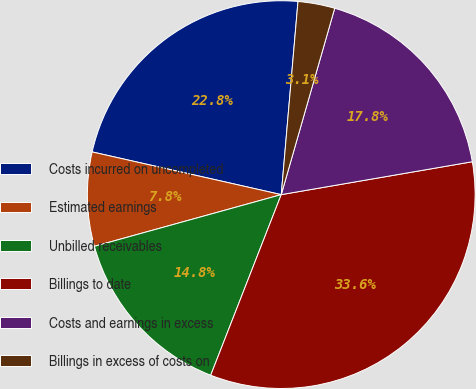Convert chart. <chart><loc_0><loc_0><loc_500><loc_500><pie_chart><fcel>Costs incurred on uncompleted<fcel>Estimated earnings<fcel>Unbilled receivables<fcel>Billings to date<fcel>Costs and earnings in excess<fcel>Billings in excess of costs on<nl><fcel>22.84%<fcel>7.83%<fcel>14.78%<fcel>33.64%<fcel>17.84%<fcel>3.07%<nl></chart> 